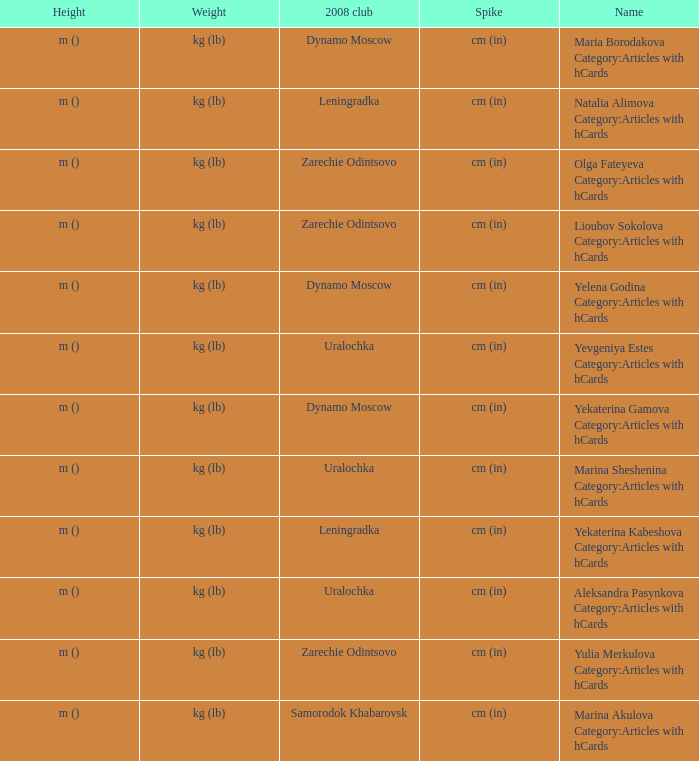What is the name when the 2008 club is uralochka? Yevgeniya Estes Category:Articles with hCards, Marina Sheshenina Category:Articles with hCards, Aleksandra Pasynkova Category:Articles with hCards. 